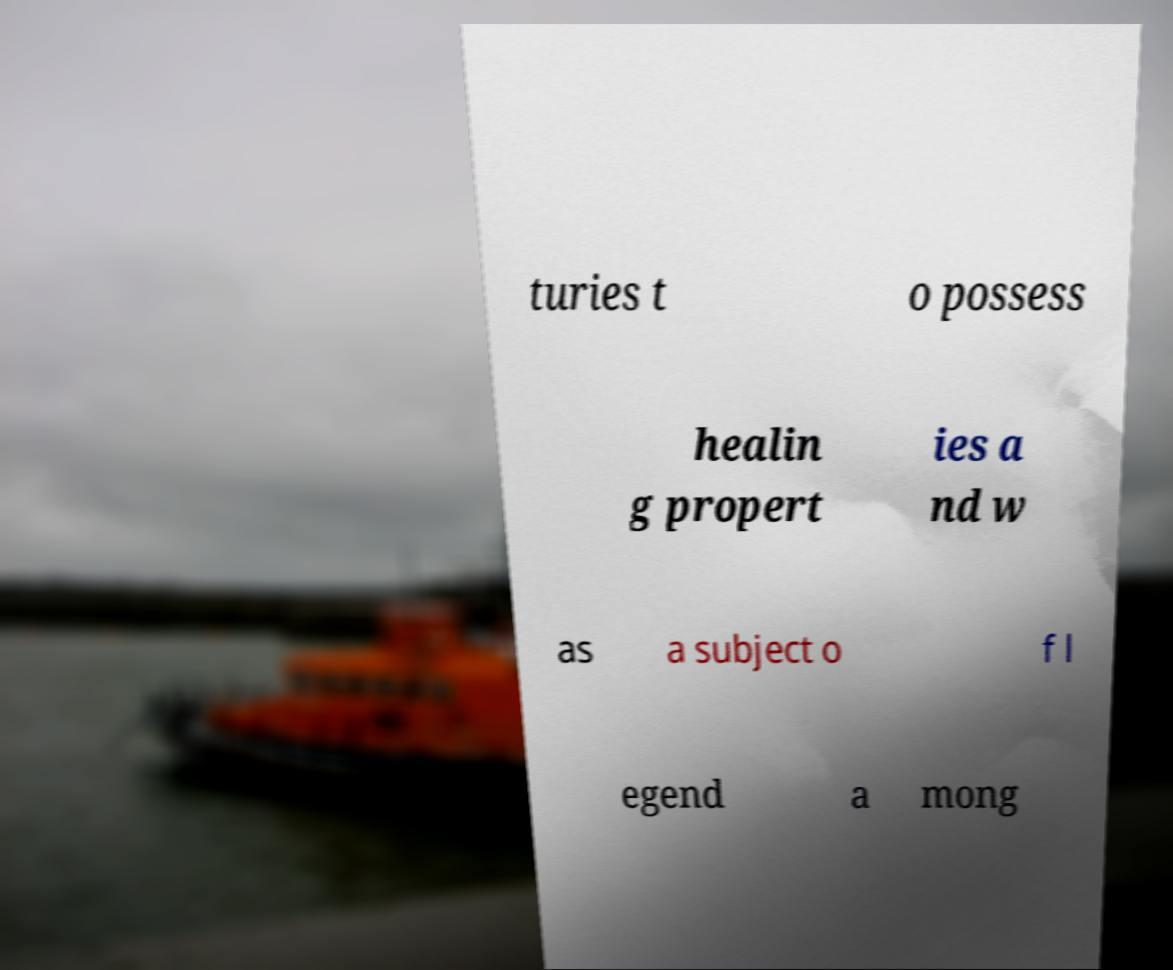Please identify and transcribe the text found in this image. turies t o possess healin g propert ies a nd w as a subject o f l egend a mong 